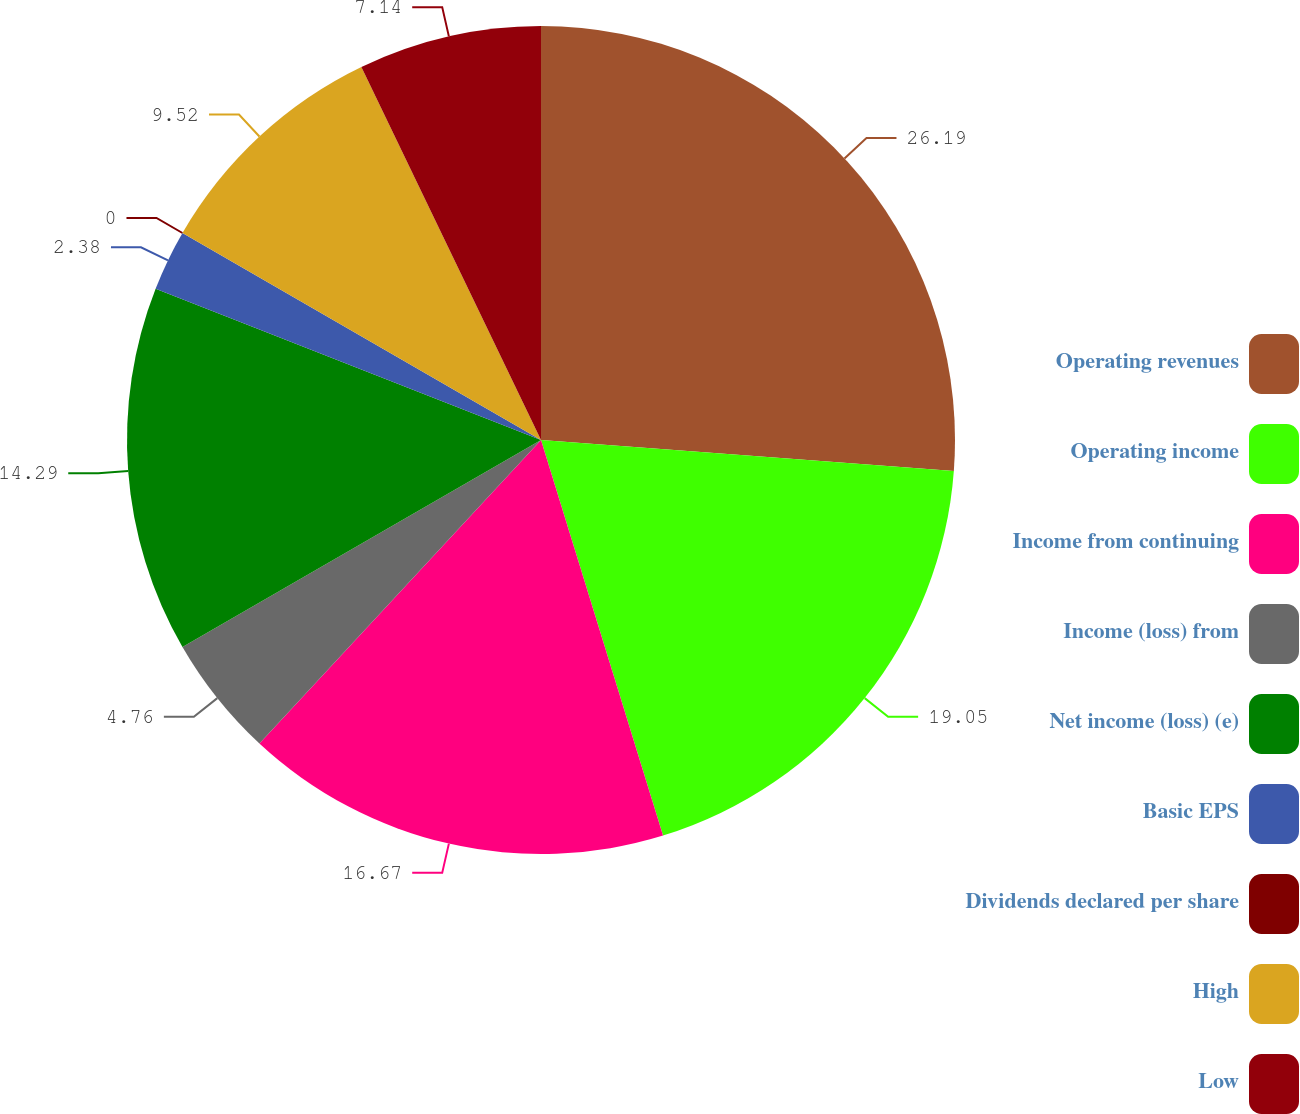Convert chart. <chart><loc_0><loc_0><loc_500><loc_500><pie_chart><fcel>Operating revenues<fcel>Operating income<fcel>Income from continuing<fcel>Income (loss) from<fcel>Net income (loss) (e)<fcel>Basic EPS<fcel>Dividends declared per share<fcel>High<fcel>Low<nl><fcel>26.18%<fcel>19.04%<fcel>16.66%<fcel>4.76%<fcel>14.28%<fcel>2.38%<fcel>0.0%<fcel>9.52%<fcel>7.14%<nl></chart> 